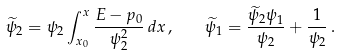Convert formula to latex. <formula><loc_0><loc_0><loc_500><loc_500>\widetilde { \psi } _ { 2 } = \psi _ { 2 } \int _ { x _ { 0 } } ^ { x } \frac { E - p _ { 0 } } { \psi _ { 2 } ^ { 2 } } \, d x \, , \quad \widetilde { \psi } _ { 1 } = \frac { \widetilde { \psi } _ { 2 } \psi _ { 1 } } { \psi _ { 2 } } + \frac { 1 } { \psi _ { 2 } } \, .</formula> 